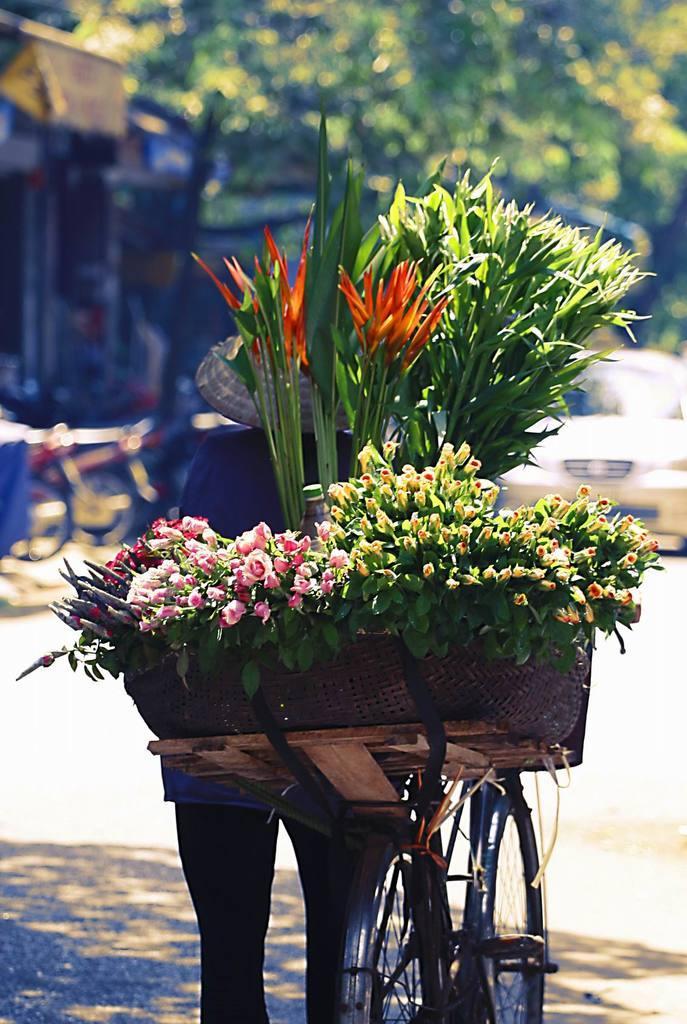How would you summarize this image in a sentence or two? In this image I can see one person and a bicycle in the front. On the back seat of the bicycle I can see number of flowers and plants. In the background I can see few trees, few more bicycles, a car, a building and I can also see this image is little bit blurry. 